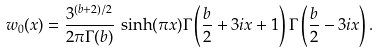<formula> <loc_0><loc_0><loc_500><loc_500>w _ { 0 } ( x ) = \frac { 3 ^ { ( b + 2 ) / 2 } } { 2 \pi \Gamma ( b ) } \, \sinh ( \pi x ) \Gamma \left ( \frac { b } { 2 } + 3 i x + 1 \right ) \Gamma \left ( \frac { b } { 2 } - 3 i x \right ) .</formula> 